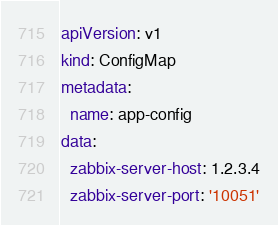<code> <loc_0><loc_0><loc_500><loc_500><_YAML_>apiVersion: v1
kind: ConfigMap
metadata:
  name: app-config
data:
  zabbix-server-host: 1.2.3.4
  zabbix-server-port: '10051'
</code> 